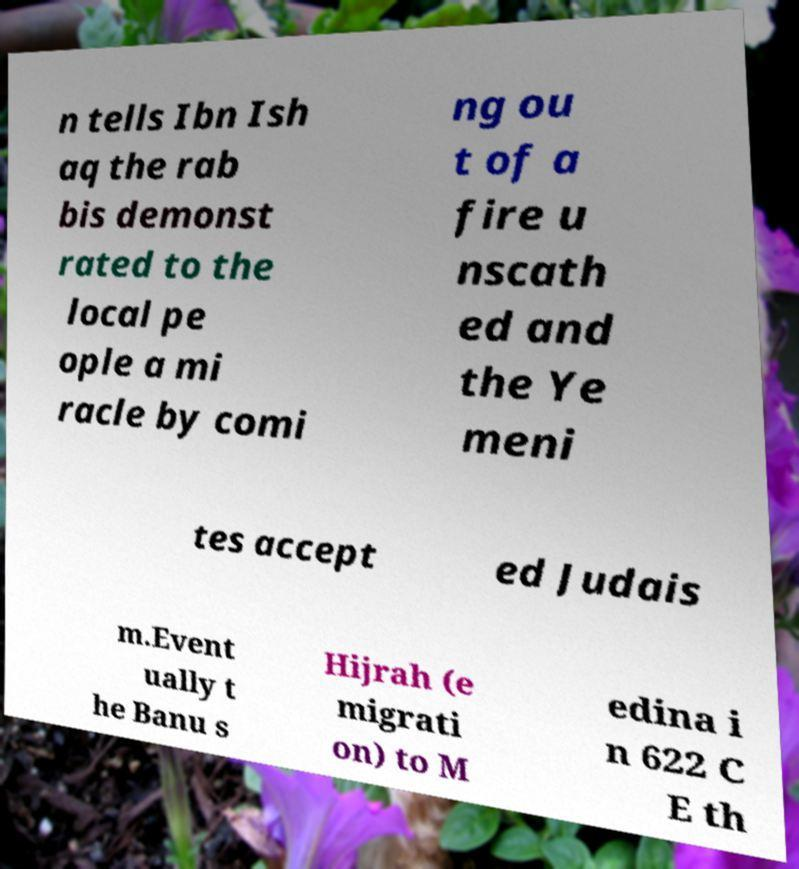Can you accurately transcribe the text from the provided image for me? n tells Ibn Ish aq the rab bis demonst rated to the local pe ople a mi racle by comi ng ou t of a fire u nscath ed and the Ye meni tes accept ed Judais m.Event ually t he Banu s Hijrah (e migrati on) to M edina i n 622 C E th 